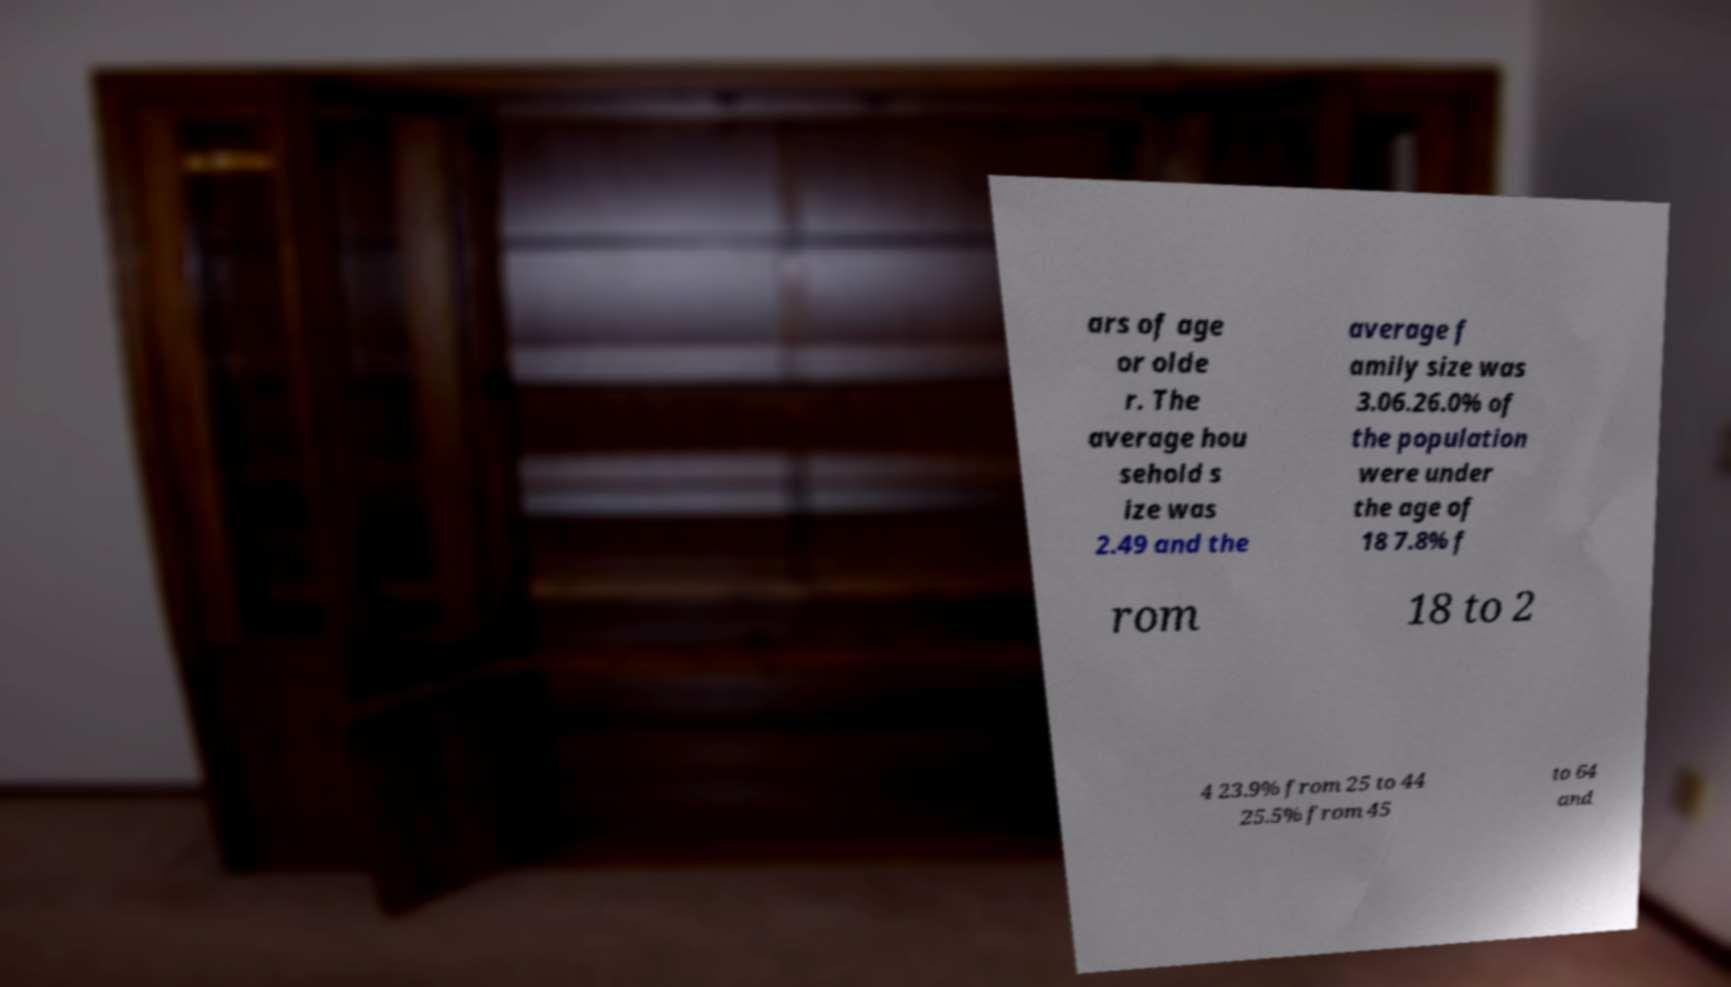Please read and relay the text visible in this image. What does it say? ars of age or olde r. The average hou sehold s ize was 2.49 and the average f amily size was 3.06.26.0% of the population were under the age of 18 7.8% f rom 18 to 2 4 23.9% from 25 to 44 25.5% from 45 to 64 and 